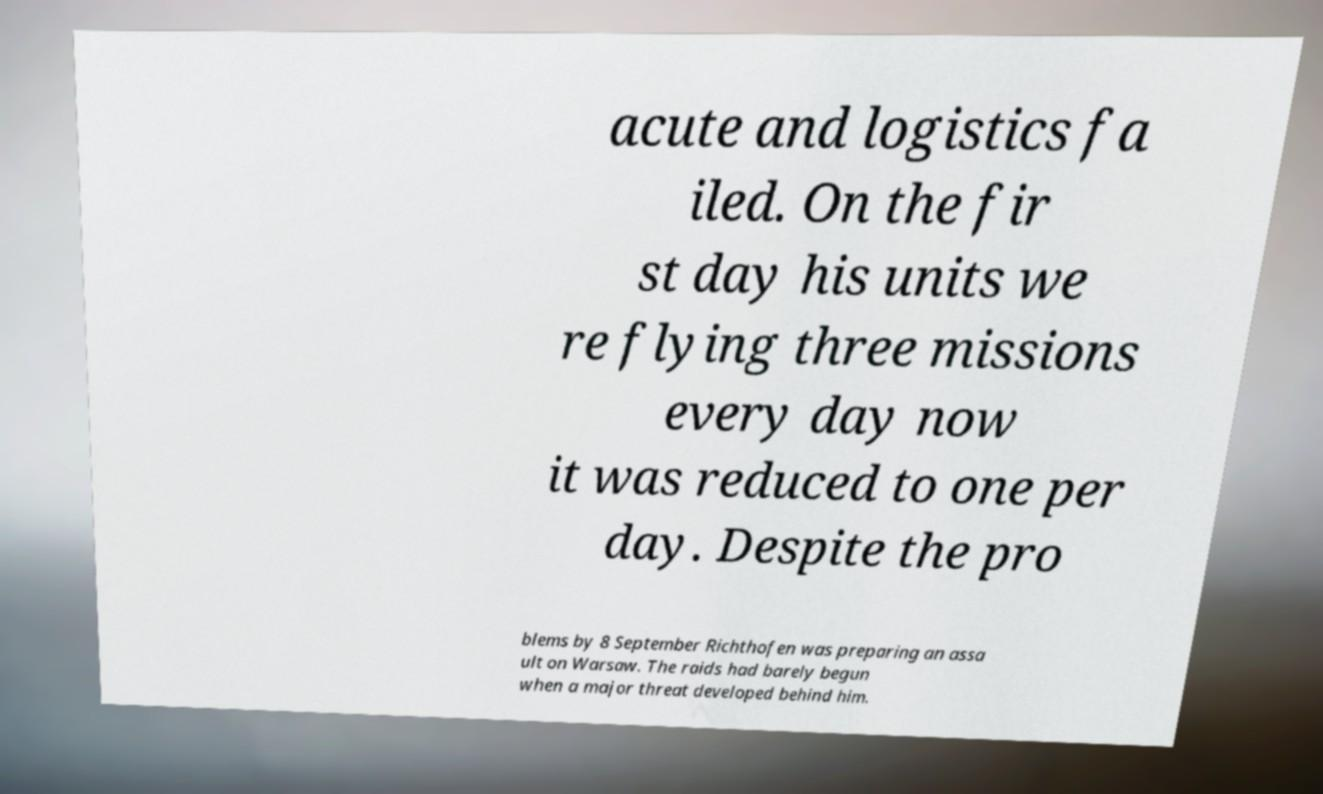What messages or text are displayed in this image? I need them in a readable, typed format. acute and logistics fa iled. On the fir st day his units we re flying three missions every day now it was reduced to one per day. Despite the pro blems by 8 September Richthofen was preparing an assa ult on Warsaw. The raids had barely begun when a major threat developed behind him. 